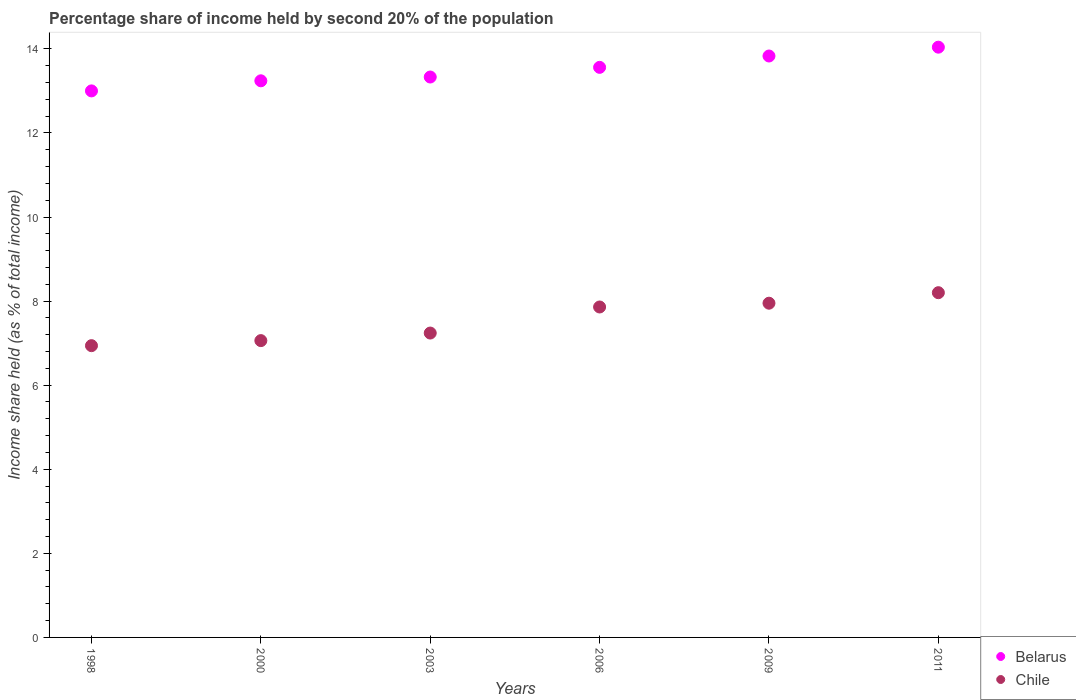How many different coloured dotlines are there?
Offer a very short reply. 2. Is the number of dotlines equal to the number of legend labels?
Make the answer very short. Yes. What is the share of income held by second 20% of the population in Chile in 1998?
Ensure brevity in your answer.  6.94. Across all years, what is the minimum share of income held by second 20% of the population in Chile?
Ensure brevity in your answer.  6.94. In which year was the share of income held by second 20% of the population in Belarus maximum?
Your response must be concise. 2011. In which year was the share of income held by second 20% of the population in Chile minimum?
Your answer should be compact. 1998. What is the total share of income held by second 20% of the population in Chile in the graph?
Provide a succinct answer. 45.25. What is the difference between the share of income held by second 20% of the population in Belarus in 2003 and that in 2011?
Your response must be concise. -0.71. What is the difference between the share of income held by second 20% of the population in Belarus in 2011 and the share of income held by second 20% of the population in Chile in 2003?
Keep it short and to the point. 6.8. What is the average share of income held by second 20% of the population in Belarus per year?
Give a very brief answer. 13.5. In the year 1998, what is the difference between the share of income held by second 20% of the population in Belarus and share of income held by second 20% of the population in Chile?
Give a very brief answer. 6.06. What is the ratio of the share of income held by second 20% of the population in Chile in 2003 to that in 2009?
Provide a short and direct response. 0.91. Is the share of income held by second 20% of the population in Belarus in 1998 less than that in 2011?
Ensure brevity in your answer.  Yes. Is the difference between the share of income held by second 20% of the population in Belarus in 2000 and 2011 greater than the difference between the share of income held by second 20% of the population in Chile in 2000 and 2011?
Your answer should be very brief. Yes. What is the difference between the highest and the second highest share of income held by second 20% of the population in Belarus?
Ensure brevity in your answer.  0.21. What is the difference between the highest and the lowest share of income held by second 20% of the population in Chile?
Offer a very short reply. 1.26. Does the share of income held by second 20% of the population in Chile monotonically increase over the years?
Your answer should be very brief. Yes. What is the difference between two consecutive major ticks on the Y-axis?
Give a very brief answer. 2. Does the graph contain grids?
Offer a very short reply. No. How many legend labels are there?
Your response must be concise. 2. How are the legend labels stacked?
Provide a succinct answer. Vertical. What is the title of the graph?
Offer a very short reply. Percentage share of income held by second 20% of the population. What is the label or title of the X-axis?
Offer a very short reply. Years. What is the label or title of the Y-axis?
Your answer should be very brief. Income share held (as % of total income). What is the Income share held (as % of total income) of Belarus in 1998?
Offer a terse response. 13. What is the Income share held (as % of total income) of Chile in 1998?
Make the answer very short. 6.94. What is the Income share held (as % of total income) in Belarus in 2000?
Make the answer very short. 13.24. What is the Income share held (as % of total income) in Chile in 2000?
Ensure brevity in your answer.  7.06. What is the Income share held (as % of total income) in Belarus in 2003?
Offer a terse response. 13.33. What is the Income share held (as % of total income) in Chile in 2003?
Provide a succinct answer. 7.24. What is the Income share held (as % of total income) of Belarus in 2006?
Provide a short and direct response. 13.56. What is the Income share held (as % of total income) in Chile in 2006?
Your answer should be compact. 7.86. What is the Income share held (as % of total income) in Belarus in 2009?
Provide a succinct answer. 13.83. What is the Income share held (as % of total income) of Chile in 2009?
Ensure brevity in your answer.  7.95. What is the Income share held (as % of total income) of Belarus in 2011?
Offer a very short reply. 14.04. What is the Income share held (as % of total income) of Chile in 2011?
Offer a very short reply. 8.2. Across all years, what is the maximum Income share held (as % of total income) of Belarus?
Give a very brief answer. 14.04. Across all years, what is the minimum Income share held (as % of total income) in Belarus?
Offer a very short reply. 13. Across all years, what is the minimum Income share held (as % of total income) in Chile?
Provide a succinct answer. 6.94. What is the total Income share held (as % of total income) in Belarus in the graph?
Your response must be concise. 81. What is the total Income share held (as % of total income) in Chile in the graph?
Your answer should be very brief. 45.25. What is the difference between the Income share held (as % of total income) of Belarus in 1998 and that in 2000?
Give a very brief answer. -0.24. What is the difference between the Income share held (as % of total income) of Chile in 1998 and that in 2000?
Ensure brevity in your answer.  -0.12. What is the difference between the Income share held (as % of total income) in Belarus in 1998 and that in 2003?
Give a very brief answer. -0.33. What is the difference between the Income share held (as % of total income) of Chile in 1998 and that in 2003?
Your answer should be compact. -0.3. What is the difference between the Income share held (as % of total income) in Belarus in 1998 and that in 2006?
Keep it short and to the point. -0.56. What is the difference between the Income share held (as % of total income) in Chile in 1998 and that in 2006?
Make the answer very short. -0.92. What is the difference between the Income share held (as % of total income) in Belarus in 1998 and that in 2009?
Provide a succinct answer. -0.83. What is the difference between the Income share held (as % of total income) in Chile in 1998 and that in 2009?
Keep it short and to the point. -1.01. What is the difference between the Income share held (as % of total income) of Belarus in 1998 and that in 2011?
Provide a short and direct response. -1.04. What is the difference between the Income share held (as % of total income) in Chile in 1998 and that in 2011?
Provide a short and direct response. -1.26. What is the difference between the Income share held (as % of total income) in Belarus in 2000 and that in 2003?
Your answer should be compact. -0.09. What is the difference between the Income share held (as % of total income) in Chile in 2000 and that in 2003?
Ensure brevity in your answer.  -0.18. What is the difference between the Income share held (as % of total income) in Belarus in 2000 and that in 2006?
Your response must be concise. -0.32. What is the difference between the Income share held (as % of total income) of Chile in 2000 and that in 2006?
Provide a succinct answer. -0.8. What is the difference between the Income share held (as % of total income) in Belarus in 2000 and that in 2009?
Provide a short and direct response. -0.59. What is the difference between the Income share held (as % of total income) in Chile in 2000 and that in 2009?
Give a very brief answer. -0.89. What is the difference between the Income share held (as % of total income) of Belarus in 2000 and that in 2011?
Provide a succinct answer. -0.8. What is the difference between the Income share held (as % of total income) of Chile in 2000 and that in 2011?
Offer a very short reply. -1.14. What is the difference between the Income share held (as % of total income) of Belarus in 2003 and that in 2006?
Ensure brevity in your answer.  -0.23. What is the difference between the Income share held (as % of total income) in Chile in 2003 and that in 2006?
Provide a succinct answer. -0.62. What is the difference between the Income share held (as % of total income) in Belarus in 2003 and that in 2009?
Make the answer very short. -0.5. What is the difference between the Income share held (as % of total income) in Chile in 2003 and that in 2009?
Your response must be concise. -0.71. What is the difference between the Income share held (as % of total income) of Belarus in 2003 and that in 2011?
Provide a short and direct response. -0.71. What is the difference between the Income share held (as % of total income) in Chile in 2003 and that in 2011?
Your response must be concise. -0.96. What is the difference between the Income share held (as % of total income) of Belarus in 2006 and that in 2009?
Give a very brief answer. -0.27. What is the difference between the Income share held (as % of total income) of Chile in 2006 and that in 2009?
Ensure brevity in your answer.  -0.09. What is the difference between the Income share held (as % of total income) of Belarus in 2006 and that in 2011?
Give a very brief answer. -0.48. What is the difference between the Income share held (as % of total income) in Chile in 2006 and that in 2011?
Your answer should be very brief. -0.34. What is the difference between the Income share held (as % of total income) of Belarus in 2009 and that in 2011?
Offer a terse response. -0.21. What is the difference between the Income share held (as % of total income) of Chile in 2009 and that in 2011?
Your response must be concise. -0.25. What is the difference between the Income share held (as % of total income) in Belarus in 1998 and the Income share held (as % of total income) in Chile in 2000?
Provide a short and direct response. 5.94. What is the difference between the Income share held (as % of total income) of Belarus in 1998 and the Income share held (as % of total income) of Chile in 2003?
Provide a short and direct response. 5.76. What is the difference between the Income share held (as % of total income) in Belarus in 1998 and the Income share held (as % of total income) in Chile in 2006?
Provide a short and direct response. 5.14. What is the difference between the Income share held (as % of total income) in Belarus in 1998 and the Income share held (as % of total income) in Chile in 2009?
Your answer should be compact. 5.05. What is the difference between the Income share held (as % of total income) in Belarus in 1998 and the Income share held (as % of total income) in Chile in 2011?
Make the answer very short. 4.8. What is the difference between the Income share held (as % of total income) in Belarus in 2000 and the Income share held (as % of total income) in Chile in 2006?
Provide a succinct answer. 5.38. What is the difference between the Income share held (as % of total income) in Belarus in 2000 and the Income share held (as % of total income) in Chile in 2009?
Your answer should be compact. 5.29. What is the difference between the Income share held (as % of total income) of Belarus in 2000 and the Income share held (as % of total income) of Chile in 2011?
Ensure brevity in your answer.  5.04. What is the difference between the Income share held (as % of total income) of Belarus in 2003 and the Income share held (as % of total income) of Chile in 2006?
Offer a terse response. 5.47. What is the difference between the Income share held (as % of total income) of Belarus in 2003 and the Income share held (as % of total income) of Chile in 2009?
Offer a terse response. 5.38. What is the difference between the Income share held (as % of total income) in Belarus in 2003 and the Income share held (as % of total income) in Chile in 2011?
Offer a terse response. 5.13. What is the difference between the Income share held (as % of total income) of Belarus in 2006 and the Income share held (as % of total income) of Chile in 2009?
Your response must be concise. 5.61. What is the difference between the Income share held (as % of total income) of Belarus in 2006 and the Income share held (as % of total income) of Chile in 2011?
Provide a succinct answer. 5.36. What is the difference between the Income share held (as % of total income) in Belarus in 2009 and the Income share held (as % of total income) in Chile in 2011?
Ensure brevity in your answer.  5.63. What is the average Income share held (as % of total income) of Belarus per year?
Ensure brevity in your answer.  13.5. What is the average Income share held (as % of total income) of Chile per year?
Keep it short and to the point. 7.54. In the year 1998, what is the difference between the Income share held (as % of total income) in Belarus and Income share held (as % of total income) in Chile?
Offer a terse response. 6.06. In the year 2000, what is the difference between the Income share held (as % of total income) in Belarus and Income share held (as % of total income) in Chile?
Ensure brevity in your answer.  6.18. In the year 2003, what is the difference between the Income share held (as % of total income) of Belarus and Income share held (as % of total income) of Chile?
Provide a short and direct response. 6.09. In the year 2006, what is the difference between the Income share held (as % of total income) in Belarus and Income share held (as % of total income) in Chile?
Keep it short and to the point. 5.7. In the year 2009, what is the difference between the Income share held (as % of total income) in Belarus and Income share held (as % of total income) in Chile?
Your response must be concise. 5.88. In the year 2011, what is the difference between the Income share held (as % of total income) in Belarus and Income share held (as % of total income) in Chile?
Ensure brevity in your answer.  5.84. What is the ratio of the Income share held (as % of total income) in Belarus in 1998 to that in 2000?
Offer a terse response. 0.98. What is the ratio of the Income share held (as % of total income) in Belarus in 1998 to that in 2003?
Provide a succinct answer. 0.98. What is the ratio of the Income share held (as % of total income) of Chile in 1998 to that in 2003?
Your response must be concise. 0.96. What is the ratio of the Income share held (as % of total income) of Belarus in 1998 to that in 2006?
Give a very brief answer. 0.96. What is the ratio of the Income share held (as % of total income) in Chile in 1998 to that in 2006?
Keep it short and to the point. 0.88. What is the ratio of the Income share held (as % of total income) of Belarus in 1998 to that in 2009?
Make the answer very short. 0.94. What is the ratio of the Income share held (as % of total income) of Chile in 1998 to that in 2009?
Your answer should be very brief. 0.87. What is the ratio of the Income share held (as % of total income) of Belarus in 1998 to that in 2011?
Make the answer very short. 0.93. What is the ratio of the Income share held (as % of total income) of Chile in 1998 to that in 2011?
Keep it short and to the point. 0.85. What is the ratio of the Income share held (as % of total income) of Chile in 2000 to that in 2003?
Your response must be concise. 0.98. What is the ratio of the Income share held (as % of total income) of Belarus in 2000 to that in 2006?
Your answer should be very brief. 0.98. What is the ratio of the Income share held (as % of total income) of Chile in 2000 to that in 2006?
Provide a short and direct response. 0.9. What is the ratio of the Income share held (as % of total income) in Belarus in 2000 to that in 2009?
Your response must be concise. 0.96. What is the ratio of the Income share held (as % of total income) in Chile in 2000 to that in 2009?
Your answer should be very brief. 0.89. What is the ratio of the Income share held (as % of total income) of Belarus in 2000 to that in 2011?
Give a very brief answer. 0.94. What is the ratio of the Income share held (as % of total income) in Chile in 2000 to that in 2011?
Keep it short and to the point. 0.86. What is the ratio of the Income share held (as % of total income) in Chile in 2003 to that in 2006?
Offer a terse response. 0.92. What is the ratio of the Income share held (as % of total income) in Belarus in 2003 to that in 2009?
Make the answer very short. 0.96. What is the ratio of the Income share held (as % of total income) of Chile in 2003 to that in 2009?
Provide a short and direct response. 0.91. What is the ratio of the Income share held (as % of total income) in Belarus in 2003 to that in 2011?
Your answer should be compact. 0.95. What is the ratio of the Income share held (as % of total income) in Chile in 2003 to that in 2011?
Provide a short and direct response. 0.88. What is the ratio of the Income share held (as % of total income) of Belarus in 2006 to that in 2009?
Your response must be concise. 0.98. What is the ratio of the Income share held (as % of total income) of Chile in 2006 to that in 2009?
Your answer should be compact. 0.99. What is the ratio of the Income share held (as % of total income) in Belarus in 2006 to that in 2011?
Give a very brief answer. 0.97. What is the ratio of the Income share held (as % of total income) of Chile in 2006 to that in 2011?
Your answer should be compact. 0.96. What is the ratio of the Income share held (as % of total income) of Belarus in 2009 to that in 2011?
Your response must be concise. 0.98. What is the ratio of the Income share held (as % of total income) of Chile in 2009 to that in 2011?
Offer a terse response. 0.97. What is the difference between the highest and the second highest Income share held (as % of total income) of Belarus?
Offer a terse response. 0.21. What is the difference between the highest and the second highest Income share held (as % of total income) in Chile?
Offer a terse response. 0.25. What is the difference between the highest and the lowest Income share held (as % of total income) of Belarus?
Your answer should be compact. 1.04. What is the difference between the highest and the lowest Income share held (as % of total income) of Chile?
Make the answer very short. 1.26. 